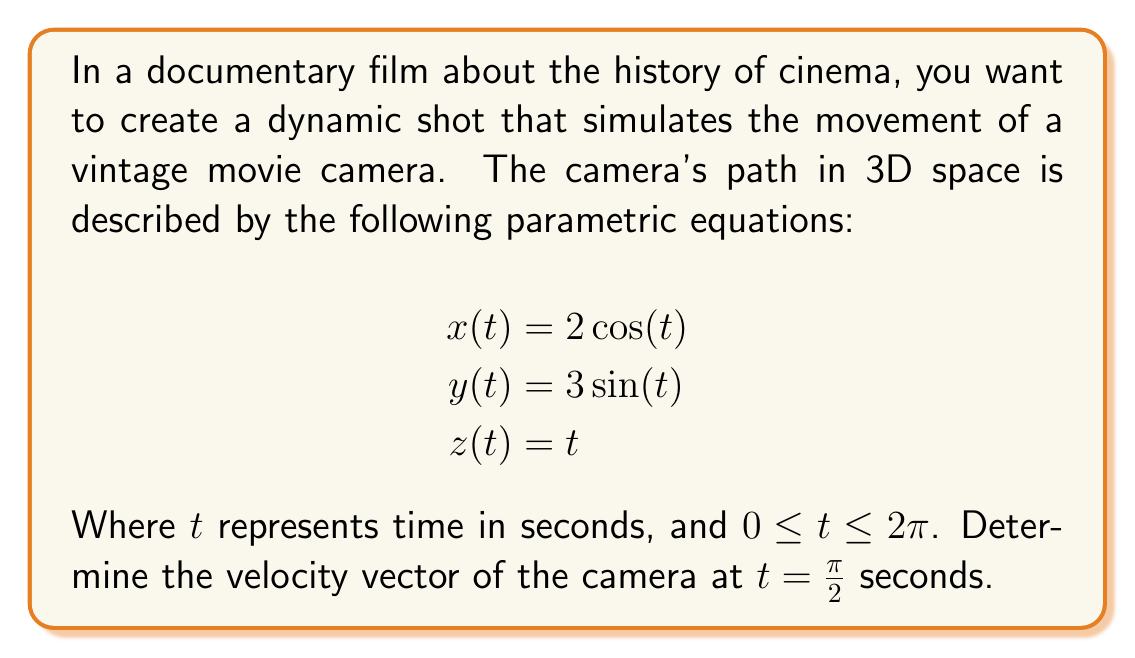Provide a solution to this math problem. To solve this problem, we need to follow these steps:

1) The velocity vector is defined as the first derivative of the position vector with respect to time. In this case, we need to find:

   $$\vec{v}(t) = \left\langle \frac{dx}{dt}, \frac{dy}{dt}, \frac{dz}{dt} \right\rangle$$

2) Let's calculate each component:

   $$\frac{dx}{dt} = -2\sin(t)$$
   $$\frac{dy}{dt} = 3\cos(t)$$
   $$\frac{dz}{dt} = 1$$

3) Therefore, the velocity vector is:

   $$\vec{v}(t) = \langle -2\sin(t), 3\cos(t), 1 \rangle$$

4) Now, we need to evaluate this at $t = \frac{\pi}{2}$:

   $$\vec{v}(\frac{\pi}{2}) = \left\langle -2\sin(\frac{\pi}{2}), 3\cos(\frac{\pi}{2}), 1 \right\rangle$$

5) Simplify:
   - $\sin(\frac{\pi}{2}) = 1$
   - $\cos(\frac{\pi}{2}) = 0$

6) Substituting these values:

   $$\vec{v}(\frac{\pi}{2}) = \langle -2, 0, 1 \rangle$$

This vector represents the instantaneous velocity of the camera at $t = \frac{\pi}{2}$ seconds.
Answer: The velocity vector of the camera at $t = \frac{\pi}{2}$ seconds is $\langle -2, 0, 1 \rangle$. 